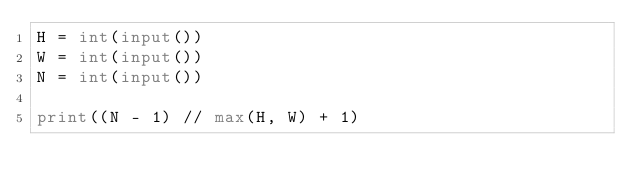Convert code to text. <code><loc_0><loc_0><loc_500><loc_500><_Python_>H = int(input())
W = int(input())
N = int(input())

print((N - 1) // max(H, W) + 1)
</code> 